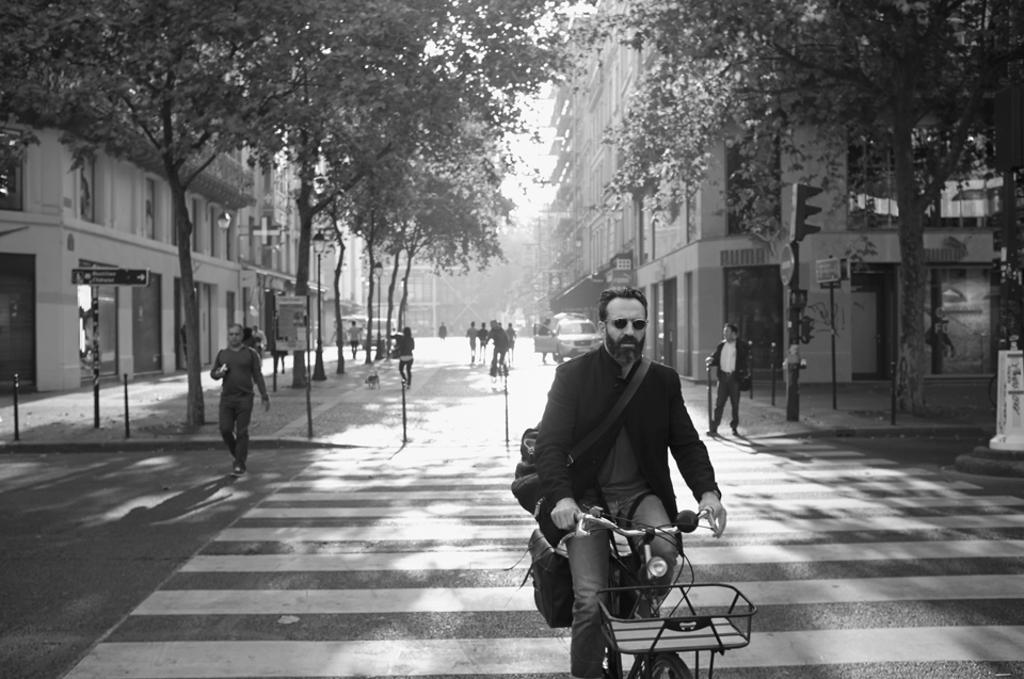What is the person in the image doing? The person is riding a bicycle. What is the person wearing while riding the bicycle? The person is wearing a black suit. What can be seen in the background of the image? There are people, buildings, and trees visible in the background. Reasoning: Let'ing: Let's think step by step in order to produce the conversation. We start by identifying the main subject in the image, which is the person riding a bicycle. Then, we describe what the person is wearing, which is a black suit. Finally, we mention the background elements, including people, buildings, and trees. Absurd Question/Answer: Can you see any hills or waves in the image? There are no hills or waves present in the image. Is there an airport visible in the background? There is no airport visible in the image; only people, buildings, and trees can be seen in the background. Can you see any hills or waves in the image? There are no hills or waves present in the image. Is there an airport visible in the background? There is no airport visible in the image; only people, buildings, and trees can be seen in the background. 